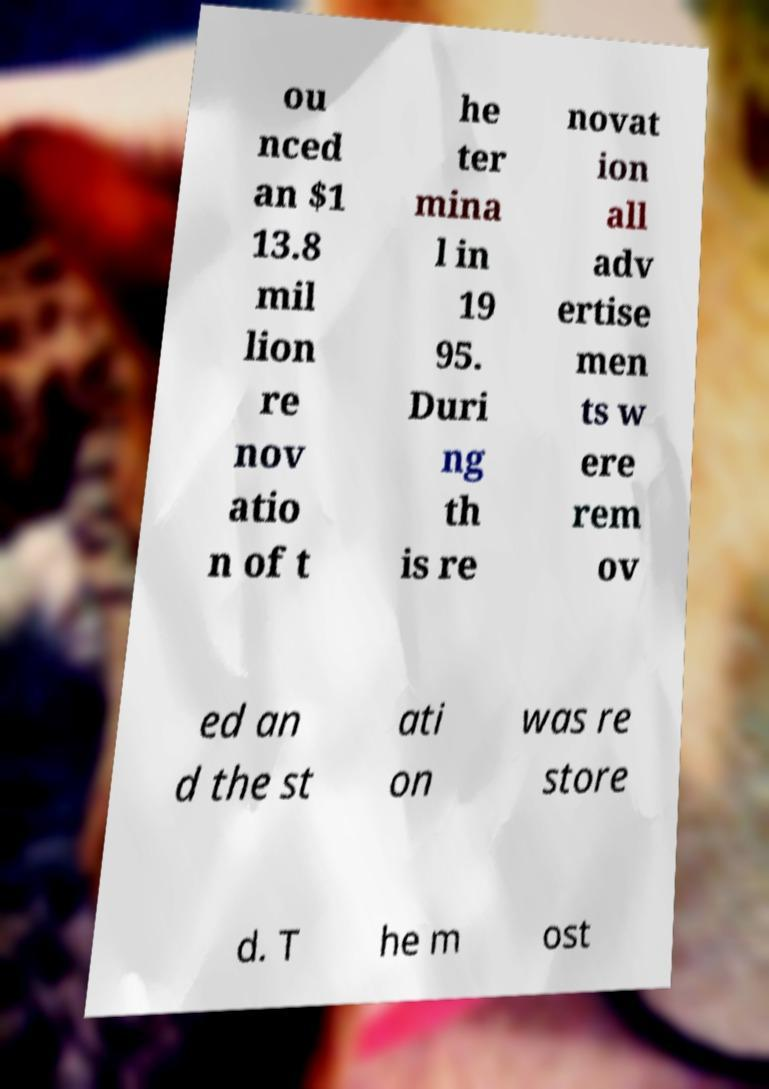Can you accurately transcribe the text from the provided image for me? ou nced an $1 13.8 mil lion re nov atio n of t he ter mina l in 19 95. Duri ng th is re novat ion all adv ertise men ts w ere rem ov ed an d the st ati on was re store d. T he m ost 